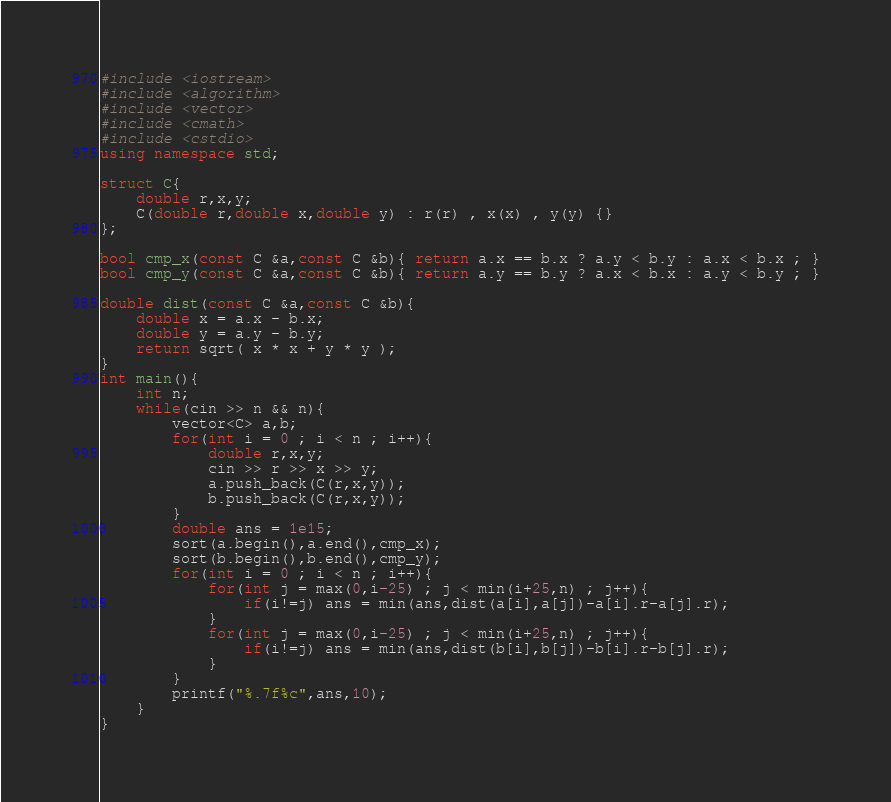Convert code to text. <code><loc_0><loc_0><loc_500><loc_500><_C++_>#include <iostream>
#include <algorithm>
#include <vector>
#include <cmath>
#include <cstdio>
using namespace std;

struct C{
	double r,x,y;
	C(double r,double x,double y) : r(r) , x(x) , y(y) {}
};

bool cmp_x(const C &a,const C &b){ return a.x == b.x ? a.y < b.y : a.x < b.x ; }
bool cmp_y(const C &a,const C &b){ return a.y == b.y ? a.x < b.x : a.y < b.y ; }

double dist(const C &a,const C &b){
	double x = a.x - b.x;
	double y = a.y - b.y;
	return sqrt( x * x + y * y );
}
int main(){
	int n;
	while(cin >> n && n){
		vector<C> a,b;
		for(int i = 0 ; i < n ; i++){
			double r,x,y;
			cin >> r >> x >> y;
			a.push_back(C(r,x,y));
			b.push_back(C(r,x,y));
		}
		double ans = 1e15;
		sort(a.begin(),a.end(),cmp_x);
		sort(b.begin(),b.end(),cmp_y);
		for(int i = 0 ; i < n ; i++){
			for(int j = max(0,i-25) ; j < min(i+25,n) ; j++){
				if(i!=j) ans = min(ans,dist(a[i],a[j])-a[i].r-a[j].r);
			}
			for(int j = max(0,i-25) ; j < min(i+25,n) ; j++){
				if(i!=j) ans = min(ans,dist(b[i],b[j])-b[i].r-b[j].r);
			}
		}
		printf("%.7f%c",ans,10);
	}
}</code> 